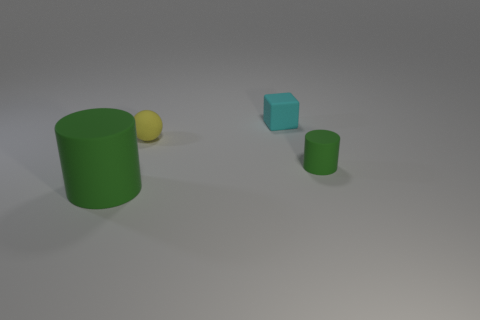The small cyan rubber thing has what shape? cube 